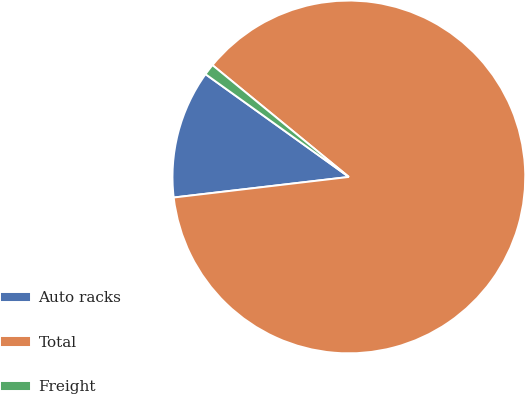Convert chart to OTSL. <chart><loc_0><loc_0><loc_500><loc_500><pie_chart><fcel>Auto racks<fcel>Total<fcel>Freight<nl><fcel>11.76%<fcel>87.21%<fcel>1.03%<nl></chart> 